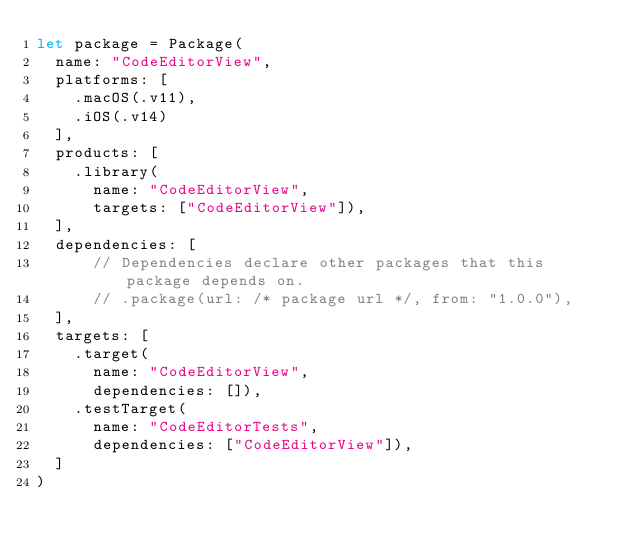<code> <loc_0><loc_0><loc_500><loc_500><_Swift_>let package = Package(
  name: "CodeEditorView",
  platforms: [
    .macOS(.v11),
    .iOS(.v14)
  ],
  products: [
    .library(
      name: "CodeEditorView",
      targets: ["CodeEditorView"]),
  ],
  dependencies: [
      // Dependencies declare other packages that this package depends on.
      // .package(url: /* package url */, from: "1.0.0"),
  ],
  targets: [
    .target(
      name: "CodeEditorView",
      dependencies: []),
    .testTarget(
      name: "CodeEditorTests",
      dependencies: ["CodeEditorView"]),
  ]
)
</code> 